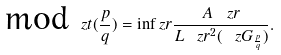Convert formula to latex. <formula><loc_0><loc_0><loc_500><loc_500>\text {mod} _ { \ } z t ( \frac { p } { q } ) = \inf _ { \ } z r \frac { A _ { \ } z r } { L _ { \ } z r ^ { 2 } ( \ z G _ { \frac { p } { q } } ) } .</formula> 